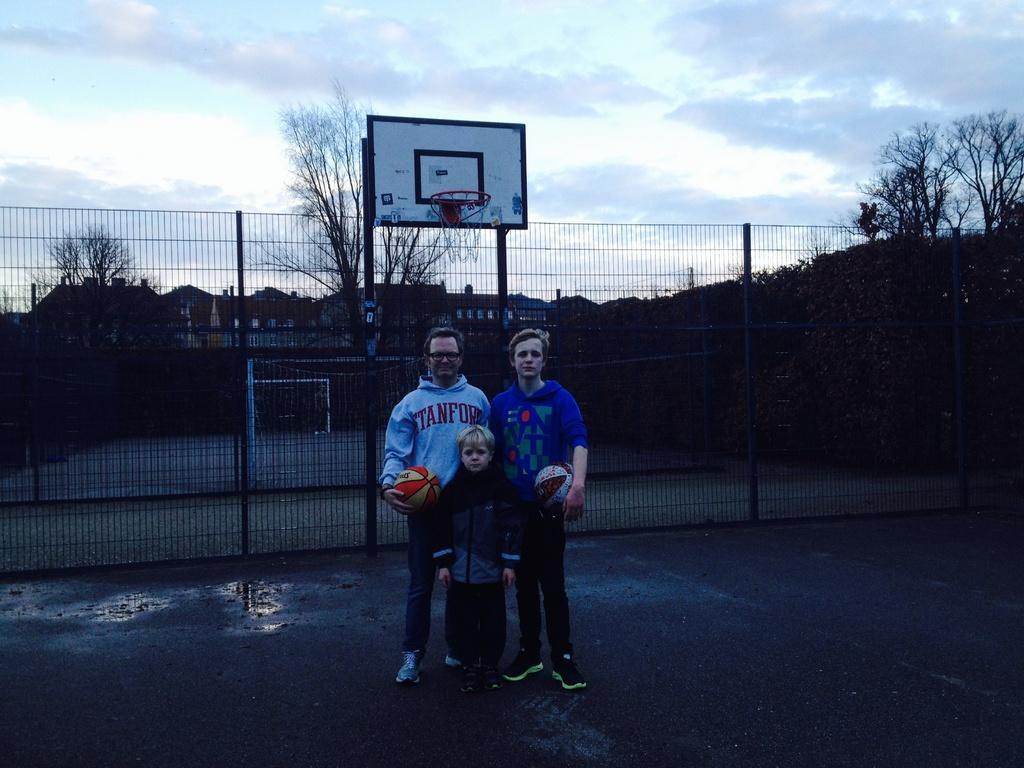Could you give a brief overview of what you see in this image? In this image there are two men and a boy standing in a basketball court, two men are holding basketballs in their hands, in the background there is a fencing, trees, houses and a sky. 